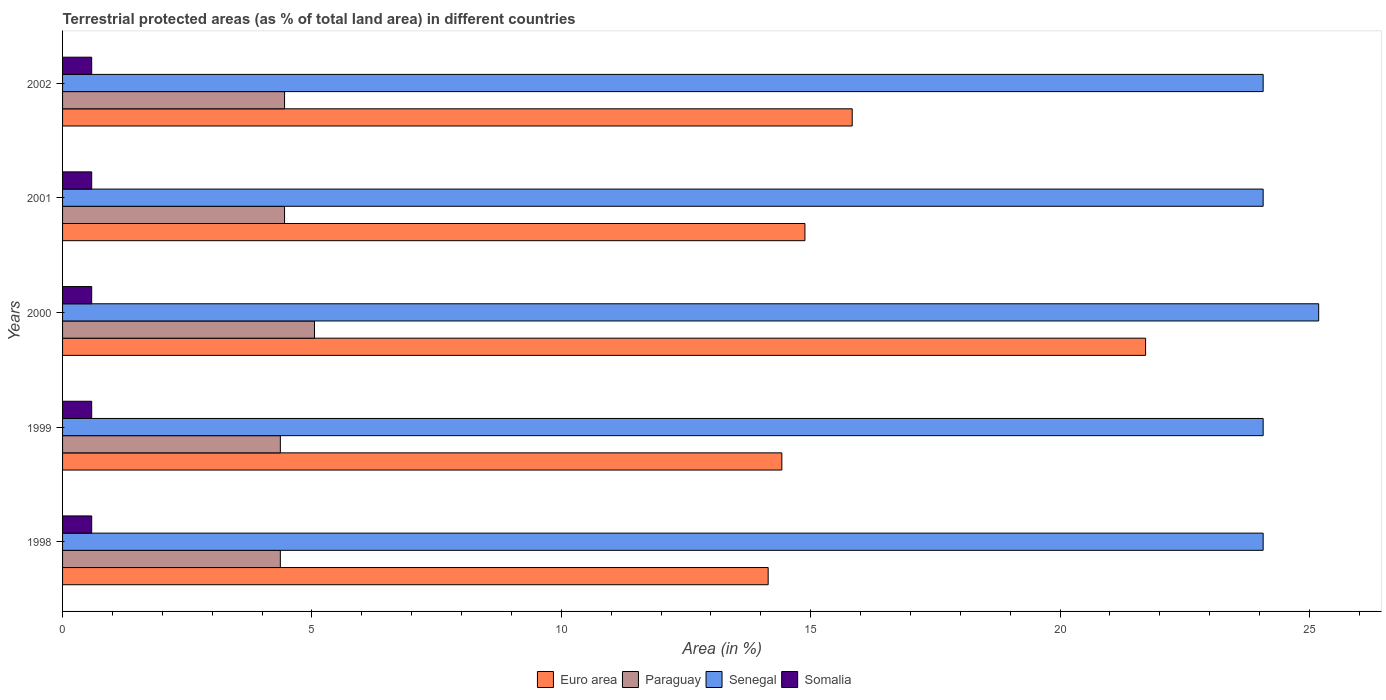How many bars are there on the 3rd tick from the top?
Keep it short and to the point. 4. How many bars are there on the 3rd tick from the bottom?
Give a very brief answer. 4. In how many cases, is the number of bars for a given year not equal to the number of legend labels?
Offer a very short reply. 0. What is the percentage of terrestrial protected land in Paraguay in 1998?
Offer a terse response. 4.37. Across all years, what is the maximum percentage of terrestrial protected land in Senegal?
Provide a short and direct response. 25.19. Across all years, what is the minimum percentage of terrestrial protected land in Euro area?
Offer a very short reply. 14.15. In which year was the percentage of terrestrial protected land in Somalia maximum?
Offer a terse response. 2000. What is the total percentage of terrestrial protected land in Euro area in the graph?
Offer a very short reply. 81.01. What is the difference between the percentage of terrestrial protected land in Euro area in 1999 and that in 2002?
Your answer should be compact. -1.41. What is the difference between the percentage of terrestrial protected land in Paraguay in 2001 and the percentage of terrestrial protected land in Euro area in 1999?
Ensure brevity in your answer.  -9.97. What is the average percentage of terrestrial protected land in Euro area per year?
Offer a very short reply. 16.2. In the year 2002, what is the difference between the percentage of terrestrial protected land in Paraguay and percentage of terrestrial protected land in Euro area?
Offer a terse response. -11.38. In how many years, is the percentage of terrestrial protected land in Somalia greater than 20 %?
Make the answer very short. 0. What is the ratio of the percentage of terrestrial protected land in Senegal in 1998 to that in 2000?
Ensure brevity in your answer.  0.96. Is the difference between the percentage of terrestrial protected land in Paraguay in 2000 and 2002 greater than the difference between the percentage of terrestrial protected land in Euro area in 2000 and 2002?
Provide a short and direct response. No. What is the difference between the highest and the second highest percentage of terrestrial protected land in Somalia?
Provide a succinct answer. 3.1765633260461e-6. What is the difference between the highest and the lowest percentage of terrestrial protected land in Somalia?
Ensure brevity in your answer.  3.1765633260461e-6. In how many years, is the percentage of terrestrial protected land in Euro area greater than the average percentage of terrestrial protected land in Euro area taken over all years?
Give a very brief answer. 1. Is it the case that in every year, the sum of the percentage of terrestrial protected land in Somalia and percentage of terrestrial protected land in Euro area is greater than the sum of percentage of terrestrial protected land in Senegal and percentage of terrestrial protected land in Paraguay?
Keep it short and to the point. No. What does the 2nd bar from the top in 2000 represents?
Offer a very short reply. Senegal. What does the 4th bar from the bottom in 2001 represents?
Give a very brief answer. Somalia. Is it the case that in every year, the sum of the percentage of terrestrial protected land in Somalia and percentage of terrestrial protected land in Senegal is greater than the percentage of terrestrial protected land in Euro area?
Provide a succinct answer. Yes. How many bars are there?
Ensure brevity in your answer.  20. Are all the bars in the graph horizontal?
Your response must be concise. Yes. How many years are there in the graph?
Your answer should be very brief. 5. What is the title of the graph?
Ensure brevity in your answer.  Terrestrial protected areas (as % of total land area) in different countries. What is the label or title of the X-axis?
Your response must be concise. Area (in %). What is the label or title of the Y-axis?
Your answer should be very brief. Years. What is the Area (in %) in Euro area in 1998?
Provide a succinct answer. 14.15. What is the Area (in %) in Paraguay in 1998?
Provide a succinct answer. 4.37. What is the Area (in %) of Senegal in 1998?
Your answer should be compact. 24.07. What is the Area (in %) of Somalia in 1998?
Keep it short and to the point. 0.58. What is the Area (in %) of Euro area in 1999?
Provide a short and direct response. 14.42. What is the Area (in %) in Paraguay in 1999?
Give a very brief answer. 4.37. What is the Area (in %) in Senegal in 1999?
Ensure brevity in your answer.  24.07. What is the Area (in %) in Somalia in 1999?
Keep it short and to the point. 0.58. What is the Area (in %) of Euro area in 2000?
Provide a succinct answer. 21.72. What is the Area (in %) in Paraguay in 2000?
Make the answer very short. 5.05. What is the Area (in %) in Senegal in 2000?
Your answer should be very brief. 25.19. What is the Area (in %) in Somalia in 2000?
Ensure brevity in your answer.  0.58. What is the Area (in %) in Euro area in 2001?
Make the answer very short. 14.89. What is the Area (in %) in Paraguay in 2001?
Your answer should be very brief. 4.45. What is the Area (in %) in Senegal in 2001?
Keep it short and to the point. 24.07. What is the Area (in %) of Somalia in 2001?
Your response must be concise. 0.58. What is the Area (in %) in Euro area in 2002?
Offer a very short reply. 15.83. What is the Area (in %) of Paraguay in 2002?
Your response must be concise. 4.45. What is the Area (in %) in Senegal in 2002?
Provide a short and direct response. 24.07. What is the Area (in %) in Somalia in 2002?
Provide a succinct answer. 0.58. Across all years, what is the maximum Area (in %) of Euro area?
Make the answer very short. 21.72. Across all years, what is the maximum Area (in %) of Paraguay?
Make the answer very short. 5.05. Across all years, what is the maximum Area (in %) in Senegal?
Your response must be concise. 25.19. Across all years, what is the maximum Area (in %) of Somalia?
Keep it short and to the point. 0.58. Across all years, what is the minimum Area (in %) of Euro area?
Provide a succinct answer. 14.15. Across all years, what is the minimum Area (in %) of Paraguay?
Offer a very short reply. 4.37. Across all years, what is the minimum Area (in %) of Senegal?
Make the answer very short. 24.07. Across all years, what is the minimum Area (in %) in Somalia?
Give a very brief answer. 0.58. What is the total Area (in %) of Euro area in the graph?
Offer a terse response. 81.01. What is the total Area (in %) of Paraguay in the graph?
Offer a very short reply. 22.69. What is the total Area (in %) in Senegal in the graph?
Offer a very short reply. 121.48. What is the total Area (in %) in Somalia in the graph?
Offer a very short reply. 2.92. What is the difference between the Area (in %) of Euro area in 1998 and that in 1999?
Ensure brevity in your answer.  -0.27. What is the difference between the Area (in %) in Euro area in 1998 and that in 2000?
Ensure brevity in your answer.  -7.57. What is the difference between the Area (in %) in Paraguay in 1998 and that in 2000?
Your answer should be compact. -0.68. What is the difference between the Area (in %) in Senegal in 1998 and that in 2000?
Offer a terse response. -1.11. What is the difference between the Area (in %) in Somalia in 1998 and that in 2000?
Provide a succinct answer. -0. What is the difference between the Area (in %) in Euro area in 1998 and that in 2001?
Ensure brevity in your answer.  -0.74. What is the difference between the Area (in %) in Paraguay in 1998 and that in 2001?
Give a very brief answer. -0.08. What is the difference between the Area (in %) in Senegal in 1998 and that in 2001?
Keep it short and to the point. 0. What is the difference between the Area (in %) of Somalia in 1998 and that in 2001?
Your answer should be very brief. 0. What is the difference between the Area (in %) in Euro area in 1998 and that in 2002?
Give a very brief answer. -1.69. What is the difference between the Area (in %) in Paraguay in 1998 and that in 2002?
Keep it short and to the point. -0.08. What is the difference between the Area (in %) in Somalia in 1998 and that in 2002?
Your answer should be very brief. 0. What is the difference between the Area (in %) of Euro area in 1999 and that in 2000?
Your response must be concise. -7.29. What is the difference between the Area (in %) of Paraguay in 1999 and that in 2000?
Your answer should be compact. -0.68. What is the difference between the Area (in %) of Senegal in 1999 and that in 2000?
Provide a short and direct response. -1.11. What is the difference between the Area (in %) in Somalia in 1999 and that in 2000?
Ensure brevity in your answer.  -0. What is the difference between the Area (in %) of Euro area in 1999 and that in 2001?
Your answer should be very brief. -0.46. What is the difference between the Area (in %) in Paraguay in 1999 and that in 2001?
Ensure brevity in your answer.  -0.08. What is the difference between the Area (in %) in Somalia in 1999 and that in 2001?
Your response must be concise. 0. What is the difference between the Area (in %) in Euro area in 1999 and that in 2002?
Offer a very short reply. -1.41. What is the difference between the Area (in %) in Paraguay in 1999 and that in 2002?
Offer a terse response. -0.08. What is the difference between the Area (in %) in Senegal in 1999 and that in 2002?
Provide a short and direct response. 0. What is the difference between the Area (in %) of Somalia in 1999 and that in 2002?
Your answer should be very brief. 0. What is the difference between the Area (in %) in Euro area in 2000 and that in 2001?
Provide a short and direct response. 6.83. What is the difference between the Area (in %) of Paraguay in 2000 and that in 2001?
Provide a succinct answer. 0.6. What is the difference between the Area (in %) in Senegal in 2000 and that in 2001?
Give a very brief answer. 1.11. What is the difference between the Area (in %) of Somalia in 2000 and that in 2001?
Your answer should be compact. 0. What is the difference between the Area (in %) of Euro area in 2000 and that in 2002?
Provide a succinct answer. 5.88. What is the difference between the Area (in %) of Paraguay in 2000 and that in 2002?
Give a very brief answer. 0.6. What is the difference between the Area (in %) of Senegal in 2000 and that in 2002?
Ensure brevity in your answer.  1.11. What is the difference between the Area (in %) of Somalia in 2000 and that in 2002?
Offer a terse response. 0. What is the difference between the Area (in %) of Euro area in 2001 and that in 2002?
Offer a very short reply. -0.95. What is the difference between the Area (in %) of Paraguay in 2001 and that in 2002?
Provide a succinct answer. 0. What is the difference between the Area (in %) in Euro area in 1998 and the Area (in %) in Paraguay in 1999?
Offer a very short reply. 9.78. What is the difference between the Area (in %) of Euro area in 1998 and the Area (in %) of Senegal in 1999?
Your answer should be compact. -9.93. What is the difference between the Area (in %) in Euro area in 1998 and the Area (in %) in Somalia in 1999?
Provide a succinct answer. 13.56. What is the difference between the Area (in %) of Paraguay in 1998 and the Area (in %) of Senegal in 1999?
Provide a short and direct response. -19.71. What is the difference between the Area (in %) of Paraguay in 1998 and the Area (in %) of Somalia in 1999?
Provide a succinct answer. 3.78. What is the difference between the Area (in %) in Senegal in 1998 and the Area (in %) in Somalia in 1999?
Provide a short and direct response. 23.49. What is the difference between the Area (in %) of Euro area in 1998 and the Area (in %) of Paraguay in 2000?
Offer a terse response. 9.1. What is the difference between the Area (in %) of Euro area in 1998 and the Area (in %) of Senegal in 2000?
Offer a very short reply. -11.04. What is the difference between the Area (in %) of Euro area in 1998 and the Area (in %) of Somalia in 2000?
Provide a succinct answer. 13.56. What is the difference between the Area (in %) of Paraguay in 1998 and the Area (in %) of Senegal in 2000?
Your answer should be compact. -20.82. What is the difference between the Area (in %) in Paraguay in 1998 and the Area (in %) in Somalia in 2000?
Your answer should be compact. 3.78. What is the difference between the Area (in %) in Senegal in 1998 and the Area (in %) in Somalia in 2000?
Offer a terse response. 23.49. What is the difference between the Area (in %) of Euro area in 1998 and the Area (in %) of Paraguay in 2001?
Offer a terse response. 9.7. What is the difference between the Area (in %) of Euro area in 1998 and the Area (in %) of Senegal in 2001?
Your response must be concise. -9.93. What is the difference between the Area (in %) of Euro area in 1998 and the Area (in %) of Somalia in 2001?
Give a very brief answer. 13.56. What is the difference between the Area (in %) in Paraguay in 1998 and the Area (in %) in Senegal in 2001?
Provide a succinct answer. -19.71. What is the difference between the Area (in %) of Paraguay in 1998 and the Area (in %) of Somalia in 2001?
Make the answer very short. 3.78. What is the difference between the Area (in %) in Senegal in 1998 and the Area (in %) in Somalia in 2001?
Offer a terse response. 23.49. What is the difference between the Area (in %) of Euro area in 1998 and the Area (in %) of Paraguay in 2002?
Offer a very short reply. 9.7. What is the difference between the Area (in %) in Euro area in 1998 and the Area (in %) in Senegal in 2002?
Your response must be concise. -9.93. What is the difference between the Area (in %) of Euro area in 1998 and the Area (in %) of Somalia in 2002?
Provide a short and direct response. 13.56. What is the difference between the Area (in %) in Paraguay in 1998 and the Area (in %) in Senegal in 2002?
Make the answer very short. -19.71. What is the difference between the Area (in %) in Paraguay in 1998 and the Area (in %) in Somalia in 2002?
Provide a short and direct response. 3.78. What is the difference between the Area (in %) of Senegal in 1998 and the Area (in %) of Somalia in 2002?
Provide a succinct answer. 23.49. What is the difference between the Area (in %) of Euro area in 1999 and the Area (in %) of Paraguay in 2000?
Provide a short and direct response. 9.37. What is the difference between the Area (in %) in Euro area in 1999 and the Area (in %) in Senegal in 2000?
Your answer should be very brief. -10.76. What is the difference between the Area (in %) in Euro area in 1999 and the Area (in %) in Somalia in 2000?
Keep it short and to the point. 13.84. What is the difference between the Area (in %) of Paraguay in 1999 and the Area (in %) of Senegal in 2000?
Your answer should be compact. -20.82. What is the difference between the Area (in %) in Paraguay in 1999 and the Area (in %) in Somalia in 2000?
Offer a terse response. 3.78. What is the difference between the Area (in %) in Senegal in 1999 and the Area (in %) in Somalia in 2000?
Offer a very short reply. 23.49. What is the difference between the Area (in %) in Euro area in 1999 and the Area (in %) in Paraguay in 2001?
Give a very brief answer. 9.97. What is the difference between the Area (in %) of Euro area in 1999 and the Area (in %) of Senegal in 2001?
Your answer should be compact. -9.65. What is the difference between the Area (in %) in Euro area in 1999 and the Area (in %) in Somalia in 2001?
Your response must be concise. 13.84. What is the difference between the Area (in %) of Paraguay in 1999 and the Area (in %) of Senegal in 2001?
Your answer should be very brief. -19.71. What is the difference between the Area (in %) in Paraguay in 1999 and the Area (in %) in Somalia in 2001?
Offer a terse response. 3.78. What is the difference between the Area (in %) in Senegal in 1999 and the Area (in %) in Somalia in 2001?
Ensure brevity in your answer.  23.49. What is the difference between the Area (in %) of Euro area in 1999 and the Area (in %) of Paraguay in 2002?
Make the answer very short. 9.97. What is the difference between the Area (in %) of Euro area in 1999 and the Area (in %) of Senegal in 2002?
Your response must be concise. -9.65. What is the difference between the Area (in %) of Euro area in 1999 and the Area (in %) of Somalia in 2002?
Your response must be concise. 13.84. What is the difference between the Area (in %) of Paraguay in 1999 and the Area (in %) of Senegal in 2002?
Your answer should be very brief. -19.71. What is the difference between the Area (in %) in Paraguay in 1999 and the Area (in %) in Somalia in 2002?
Your answer should be compact. 3.78. What is the difference between the Area (in %) in Senegal in 1999 and the Area (in %) in Somalia in 2002?
Offer a terse response. 23.49. What is the difference between the Area (in %) of Euro area in 2000 and the Area (in %) of Paraguay in 2001?
Provide a short and direct response. 17.26. What is the difference between the Area (in %) of Euro area in 2000 and the Area (in %) of Senegal in 2001?
Your answer should be compact. -2.36. What is the difference between the Area (in %) in Euro area in 2000 and the Area (in %) in Somalia in 2001?
Keep it short and to the point. 21.13. What is the difference between the Area (in %) of Paraguay in 2000 and the Area (in %) of Senegal in 2001?
Your response must be concise. -19.02. What is the difference between the Area (in %) of Paraguay in 2000 and the Area (in %) of Somalia in 2001?
Your answer should be very brief. 4.47. What is the difference between the Area (in %) in Senegal in 2000 and the Area (in %) in Somalia in 2001?
Your answer should be very brief. 24.6. What is the difference between the Area (in %) of Euro area in 2000 and the Area (in %) of Paraguay in 2002?
Provide a succinct answer. 17.26. What is the difference between the Area (in %) in Euro area in 2000 and the Area (in %) in Senegal in 2002?
Your answer should be compact. -2.36. What is the difference between the Area (in %) of Euro area in 2000 and the Area (in %) of Somalia in 2002?
Your answer should be compact. 21.13. What is the difference between the Area (in %) in Paraguay in 2000 and the Area (in %) in Senegal in 2002?
Offer a very short reply. -19.02. What is the difference between the Area (in %) in Paraguay in 2000 and the Area (in %) in Somalia in 2002?
Give a very brief answer. 4.47. What is the difference between the Area (in %) of Senegal in 2000 and the Area (in %) of Somalia in 2002?
Your answer should be very brief. 24.6. What is the difference between the Area (in %) in Euro area in 2001 and the Area (in %) in Paraguay in 2002?
Offer a terse response. 10.43. What is the difference between the Area (in %) of Euro area in 2001 and the Area (in %) of Senegal in 2002?
Provide a succinct answer. -9.19. What is the difference between the Area (in %) in Euro area in 2001 and the Area (in %) in Somalia in 2002?
Make the answer very short. 14.3. What is the difference between the Area (in %) in Paraguay in 2001 and the Area (in %) in Senegal in 2002?
Your answer should be compact. -19.62. What is the difference between the Area (in %) in Paraguay in 2001 and the Area (in %) in Somalia in 2002?
Provide a succinct answer. 3.87. What is the difference between the Area (in %) in Senegal in 2001 and the Area (in %) in Somalia in 2002?
Your response must be concise. 23.49. What is the average Area (in %) in Euro area per year?
Give a very brief answer. 16.2. What is the average Area (in %) of Paraguay per year?
Your response must be concise. 4.54. What is the average Area (in %) in Senegal per year?
Give a very brief answer. 24.3. What is the average Area (in %) in Somalia per year?
Keep it short and to the point. 0.58. In the year 1998, what is the difference between the Area (in %) of Euro area and Area (in %) of Paraguay?
Provide a succinct answer. 9.78. In the year 1998, what is the difference between the Area (in %) in Euro area and Area (in %) in Senegal?
Provide a succinct answer. -9.93. In the year 1998, what is the difference between the Area (in %) in Euro area and Area (in %) in Somalia?
Offer a terse response. 13.56. In the year 1998, what is the difference between the Area (in %) in Paraguay and Area (in %) in Senegal?
Give a very brief answer. -19.71. In the year 1998, what is the difference between the Area (in %) of Paraguay and Area (in %) of Somalia?
Provide a succinct answer. 3.78. In the year 1998, what is the difference between the Area (in %) of Senegal and Area (in %) of Somalia?
Your response must be concise. 23.49. In the year 1999, what is the difference between the Area (in %) of Euro area and Area (in %) of Paraguay?
Your response must be concise. 10.06. In the year 1999, what is the difference between the Area (in %) of Euro area and Area (in %) of Senegal?
Your answer should be compact. -9.65. In the year 1999, what is the difference between the Area (in %) of Euro area and Area (in %) of Somalia?
Give a very brief answer. 13.84. In the year 1999, what is the difference between the Area (in %) in Paraguay and Area (in %) in Senegal?
Offer a very short reply. -19.71. In the year 1999, what is the difference between the Area (in %) in Paraguay and Area (in %) in Somalia?
Offer a very short reply. 3.78. In the year 1999, what is the difference between the Area (in %) in Senegal and Area (in %) in Somalia?
Ensure brevity in your answer.  23.49. In the year 2000, what is the difference between the Area (in %) of Euro area and Area (in %) of Paraguay?
Give a very brief answer. 16.67. In the year 2000, what is the difference between the Area (in %) in Euro area and Area (in %) in Senegal?
Your answer should be compact. -3.47. In the year 2000, what is the difference between the Area (in %) of Euro area and Area (in %) of Somalia?
Offer a terse response. 21.13. In the year 2000, what is the difference between the Area (in %) in Paraguay and Area (in %) in Senegal?
Keep it short and to the point. -20.14. In the year 2000, what is the difference between the Area (in %) in Paraguay and Area (in %) in Somalia?
Provide a succinct answer. 4.47. In the year 2000, what is the difference between the Area (in %) in Senegal and Area (in %) in Somalia?
Offer a very short reply. 24.6. In the year 2001, what is the difference between the Area (in %) of Euro area and Area (in %) of Paraguay?
Give a very brief answer. 10.43. In the year 2001, what is the difference between the Area (in %) of Euro area and Area (in %) of Senegal?
Make the answer very short. -9.19. In the year 2001, what is the difference between the Area (in %) of Euro area and Area (in %) of Somalia?
Your response must be concise. 14.3. In the year 2001, what is the difference between the Area (in %) in Paraguay and Area (in %) in Senegal?
Your answer should be very brief. -19.62. In the year 2001, what is the difference between the Area (in %) of Paraguay and Area (in %) of Somalia?
Offer a very short reply. 3.87. In the year 2001, what is the difference between the Area (in %) of Senegal and Area (in %) of Somalia?
Ensure brevity in your answer.  23.49. In the year 2002, what is the difference between the Area (in %) in Euro area and Area (in %) in Paraguay?
Your response must be concise. 11.38. In the year 2002, what is the difference between the Area (in %) in Euro area and Area (in %) in Senegal?
Provide a succinct answer. -8.24. In the year 2002, what is the difference between the Area (in %) of Euro area and Area (in %) of Somalia?
Provide a short and direct response. 15.25. In the year 2002, what is the difference between the Area (in %) of Paraguay and Area (in %) of Senegal?
Provide a short and direct response. -19.62. In the year 2002, what is the difference between the Area (in %) in Paraguay and Area (in %) in Somalia?
Provide a short and direct response. 3.87. In the year 2002, what is the difference between the Area (in %) of Senegal and Area (in %) of Somalia?
Give a very brief answer. 23.49. What is the ratio of the Area (in %) in Euro area in 1998 to that in 1999?
Keep it short and to the point. 0.98. What is the ratio of the Area (in %) of Paraguay in 1998 to that in 1999?
Provide a succinct answer. 1. What is the ratio of the Area (in %) of Somalia in 1998 to that in 1999?
Your answer should be very brief. 1. What is the ratio of the Area (in %) of Euro area in 1998 to that in 2000?
Your answer should be compact. 0.65. What is the ratio of the Area (in %) in Paraguay in 1998 to that in 2000?
Your response must be concise. 0.86. What is the ratio of the Area (in %) in Senegal in 1998 to that in 2000?
Provide a succinct answer. 0.96. What is the ratio of the Area (in %) of Euro area in 1998 to that in 2001?
Provide a succinct answer. 0.95. What is the ratio of the Area (in %) of Paraguay in 1998 to that in 2001?
Offer a very short reply. 0.98. What is the ratio of the Area (in %) in Euro area in 1998 to that in 2002?
Keep it short and to the point. 0.89. What is the ratio of the Area (in %) in Somalia in 1998 to that in 2002?
Your response must be concise. 1. What is the ratio of the Area (in %) in Euro area in 1999 to that in 2000?
Your answer should be compact. 0.66. What is the ratio of the Area (in %) in Paraguay in 1999 to that in 2000?
Keep it short and to the point. 0.86. What is the ratio of the Area (in %) in Senegal in 1999 to that in 2000?
Offer a terse response. 0.96. What is the ratio of the Area (in %) in Somalia in 1999 to that in 2000?
Give a very brief answer. 1. What is the ratio of the Area (in %) of Euro area in 1999 to that in 2001?
Your response must be concise. 0.97. What is the ratio of the Area (in %) in Paraguay in 1999 to that in 2001?
Give a very brief answer. 0.98. What is the ratio of the Area (in %) of Somalia in 1999 to that in 2001?
Ensure brevity in your answer.  1. What is the ratio of the Area (in %) of Euro area in 1999 to that in 2002?
Your response must be concise. 0.91. What is the ratio of the Area (in %) in Senegal in 1999 to that in 2002?
Keep it short and to the point. 1. What is the ratio of the Area (in %) of Somalia in 1999 to that in 2002?
Your response must be concise. 1. What is the ratio of the Area (in %) in Euro area in 2000 to that in 2001?
Your response must be concise. 1.46. What is the ratio of the Area (in %) in Paraguay in 2000 to that in 2001?
Ensure brevity in your answer.  1.13. What is the ratio of the Area (in %) of Senegal in 2000 to that in 2001?
Your answer should be very brief. 1.05. What is the ratio of the Area (in %) of Euro area in 2000 to that in 2002?
Provide a short and direct response. 1.37. What is the ratio of the Area (in %) in Paraguay in 2000 to that in 2002?
Provide a succinct answer. 1.13. What is the ratio of the Area (in %) of Senegal in 2000 to that in 2002?
Keep it short and to the point. 1.05. What is the ratio of the Area (in %) of Somalia in 2000 to that in 2002?
Ensure brevity in your answer.  1. What is the ratio of the Area (in %) in Euro area in 2001 to that in 2002?
Give a very brief answer. 0.94. What is the ratio of the Area (in %) of Senegal in 2001 to that in 2002?
Keep it short and to the point. 1. What is the difference between the highest and the second highest Area (in %) of Euro area?
Ensure brevity in your answer.  5.88. What is the difference between the highest and the second highest Area (in %) of Paraguay?
Provide a succinct answer. 0.6. What is the difference between the highest and the second highest Area (in %) in Senegal?
Your response must be concise. 1.11. What is the difference between the highest and the lowest Area (in %) in Euro area?
Make the answer very short. 7.57. What is the difference between the highest and the lowest Area (in %) of Paraguay?
Provide a short and direct response. 0.68. What is the difference between the highest and the lowest Area (in %) in Senegal?
Offer a terse response. 1.11. 